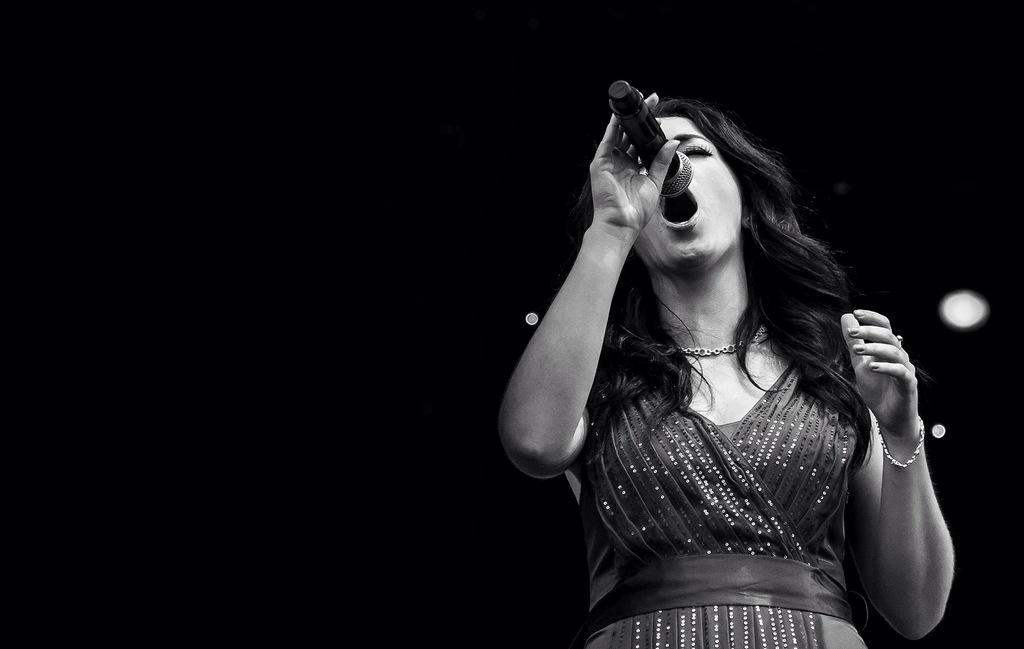Describe this image in one or two sentences. In this image, In the right side there is a woman standing and she is holding a microphone which is in black color and she is singing in the microphone. 